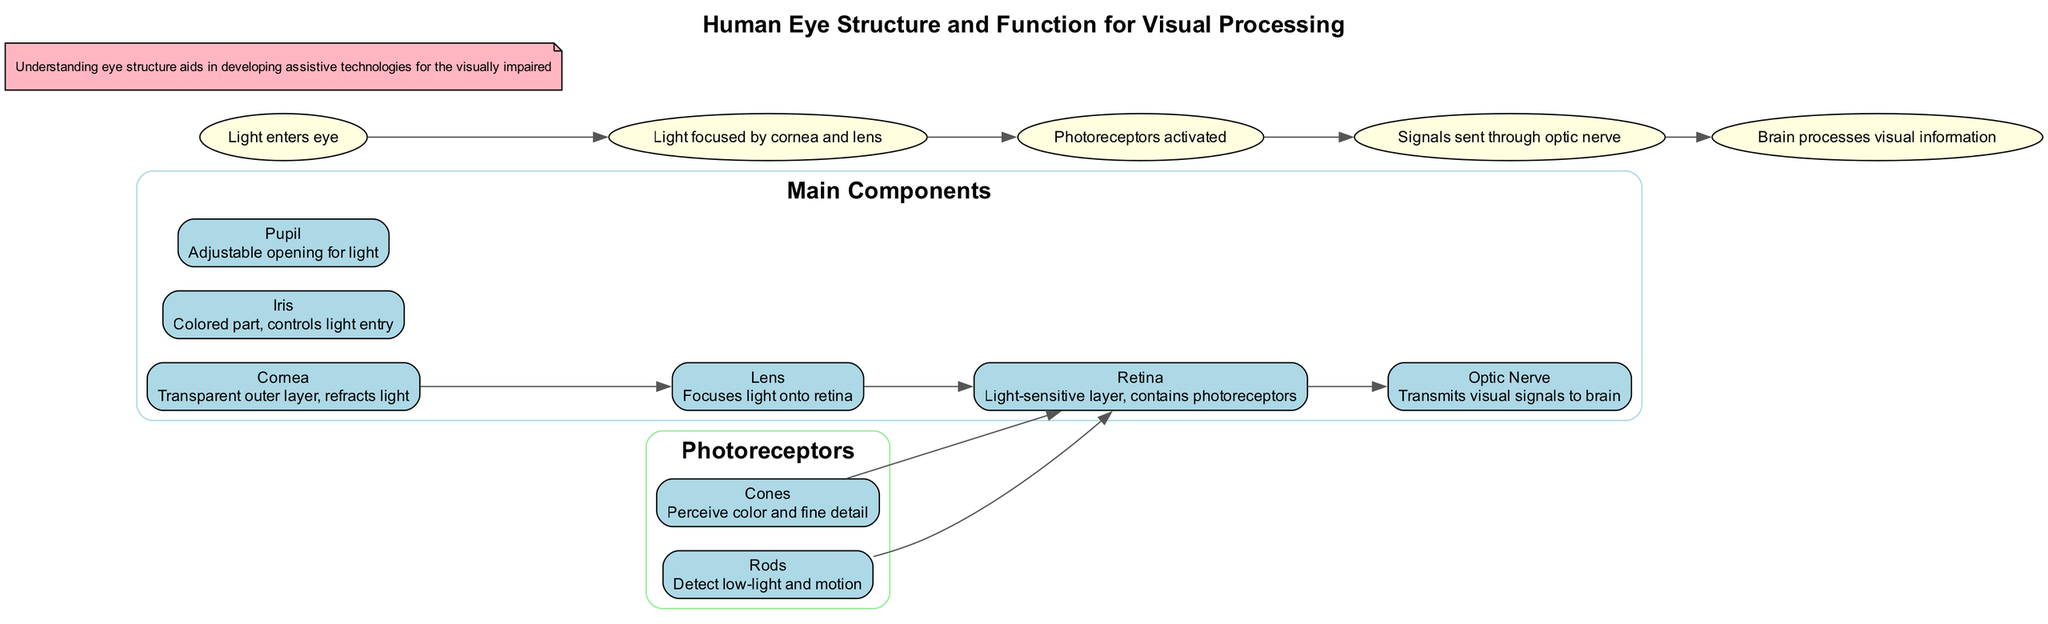What is the first component light interacts with? The diagram shows that light enters the eye through the Cornea, which is the first structure light encounters.
Answer: Cornea How many types of photoreceptors are there? The diagram includes two types of photoreceptors, listed as Rods and Cones.
Answer: Two What is the function of the Lens? According to the diagram, the Lens focuses light onto the retina, highlighting its key role in visual processing.
Answer: Focuses light onto retina Which component transmits visual signals to the brain? The diagram specifies that the Optic Nerve is responsible for transmitting visual signals from the retina to the brain.
Answer: Optic Nerve What are the two functions attributed to Rods? The diagram notes that Rods detect low-light conditions and motion, which are critical for night vision.
Answer: Detect low-light and motion Explain the flow of visual processing starting from the entrance of light until it reaches the brain. The diagram outlines the following steps: Light enters the eye through the Cornea, is focused by the Lens, activates the Photoreceptors in the Retina, and then the signals are sent through the Optic Nerve to the brain for processing. This sequence illustrates how visual information is captured and conveyed.
Answer: Light enters eye, focused by cornea and lens, photoreceptors activated, signals sent through optic nerve, brain processes visual information What separates the main components from the photoreceptors in the diagram? The diagram uses subgraphs labeled 'Main Components' and 'Photoreceptors' to visually distinguish between these two groups, highlighting their different roles in the visual system.
Answer: Subgraphs Which part of the eye controls the amount of light entering? The diagram identifies the Iris as the part that controls the size of the Pupil, thus regulating the light that enters the eye.
Answer: Iris 